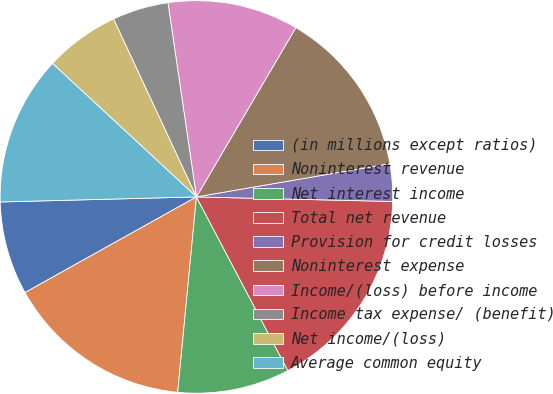Convert chart to OTSL. <chart><loc_0><loc_0><loc_500><loc_500><pie_chart><fcel>(in millions except ratios)<fcel>Noninterest revenue<fcel>Net interest income<fcel>Total net revenue<fcel>Provision for credit losses<fcel>Noninterest expense<fcel>Income/(loss) before income<fcel>Income tax expense/ (benefit)<fcel>Net income/(loss)<fcel>Average common equity<nl><fcel>7.69%<fcel>15.38%<fcel>9.23%<fcel>16.92%<fcel>3.08%<fcel>13.84%<fcel>10.77%<fcel>4.62%<fcel>6.16%<fcel>12.31%<nl></chart> 